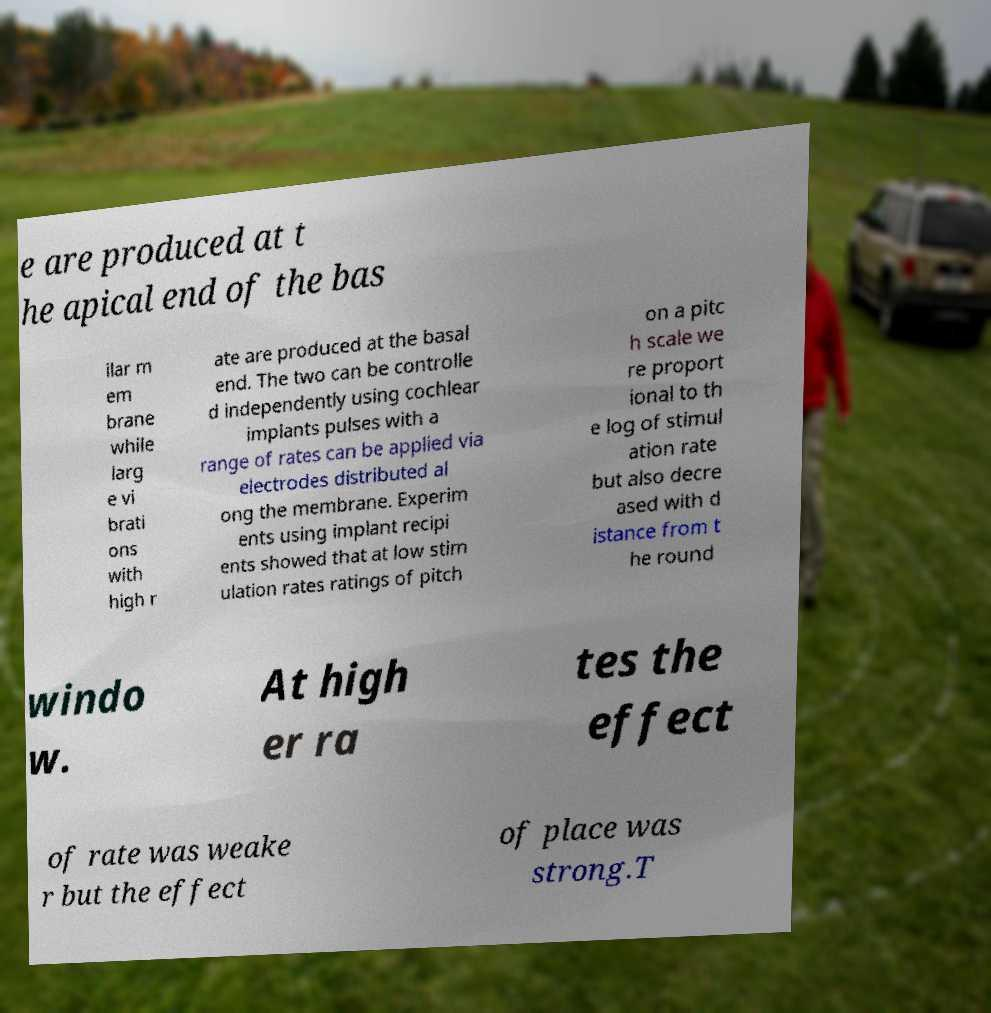I need the written content from this picture converted into text. Can you do that? e are produced at t he apical end of the bas ilar m em brane while larg e vi brati ons with high r ate are produced at the basal end. The two can be controlle d independently using cochlear implants pulses with a range of rates can be applied via electrodes distributed al ong the membrane. Experim ents using implant recipi ents showed that at low stim ulation rates ratings of pitch on a pitc h scale we re proport ional to th e log of stimul ation rate but also decre ased with d istance from t he round windo w. At high er ra tes the effect of rate was weake r but the effect of place was strong.T 